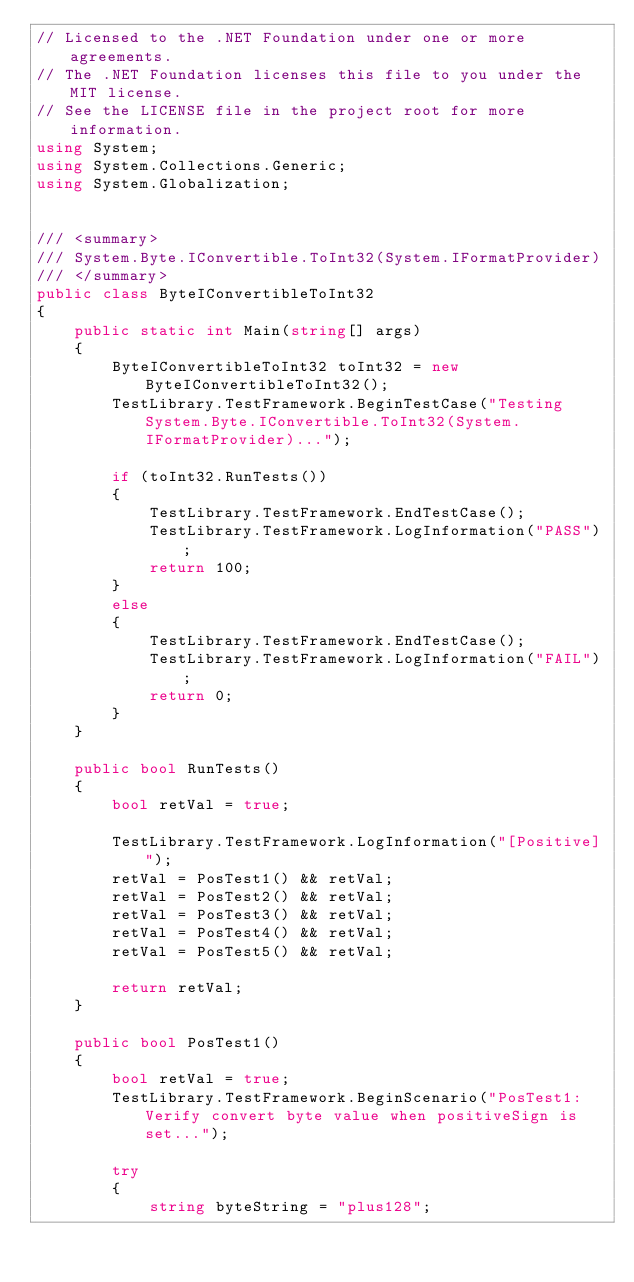Convert code to text. <code><loc_0><loc_0><loc_500><loc_500><_C#_>// Licensed to the .NET Foundation under one or more agreements.
// The .NET Foundation licenses this file to you under the MIT license.
// See the LICENSE file in the project root for more information.
using System;
using System.Collections.Generic;
using System.Globalization;


/// <summary>
/// System.Byte.IConvertible.ToInt32(System.IFormatProvider)
/// </summary>
public class ByteIConvertibleToInt32
{
    public static int Main(string[] args)
    {
        ByteIConvertibleToInt32 toInt32 = new ByteIConvertibleToInt32();
        TestLibrary.TestFramework.BeginTestCase("Testing System.Byte.IConvertible.ToInt32(System.IFormatProvider)...");

        if (toInt32.RunTests())
        {
            TestLibrary.TestFramework.EndTestCase();
            TestLibrary.TestFramework.LogInformation("PASS");
            return 100;
        }
        else
        {
            TestLibrary.TestFramework.EndTestCase();
            TestLibrary.TestFramework.LogInformation("FAIL");
            return 0;
        }
    }

    public bool RunTests()
    {
        bool retVal = true;

        TestLibrary.TestFramework.LogInformation("[Positive]");
        retVal = PosTest1() && retVal;
        retVal = PosTest2() && retVal;
        retVal = PosTest3() && retVal;
        retVal = PosTest4() && retVal;
        retVal = PosTest5() && retVal;

        return retVal;
    }

    public bool PosTest1()
    {
        bool retVal = true;
        TestLibrary.TestFramework.BeginScenario("PosTest1: Verify convert byte value when positiveSign is set...");

        try
        {
            string byteString = "plus128";</code> 